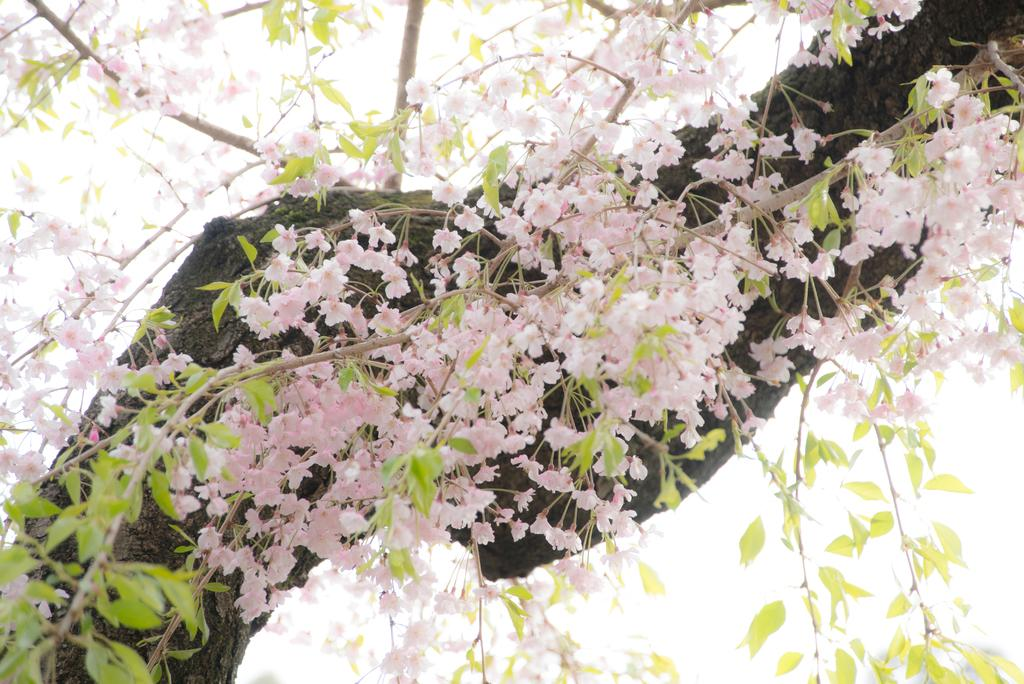What type of plant is depicted in the image? There is a flowers tree in the image. What action is the stick performing in the image? There is no stick present in the image, and therefore no such action can be observed. 